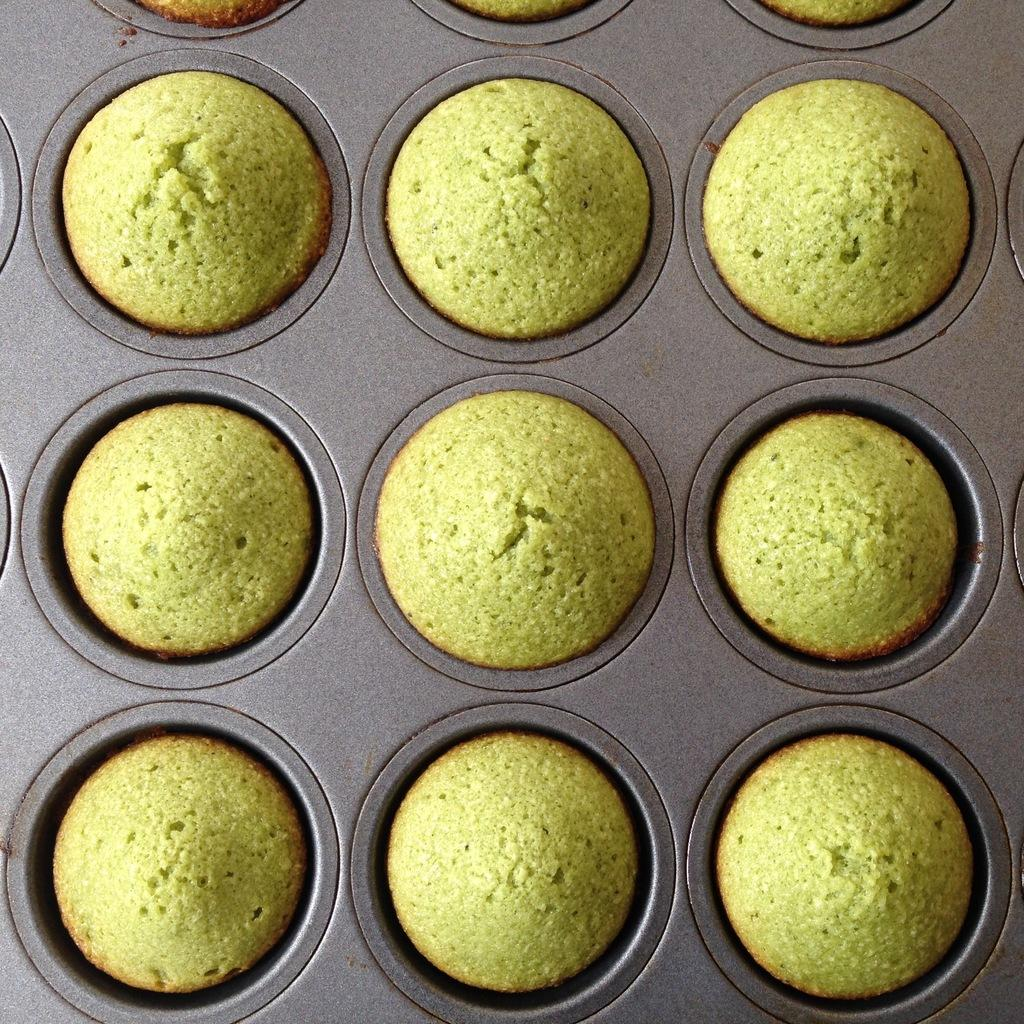What type of food can be seen in the image? There are cookies in a tray in the image. How are the cookies arranged in the tray? The provided facts do not specify the arrangement of the cookies in the tray. What might someone be about to do with the cookies in the image? Someone might be about to eat the cookies or serve them to others. What type of tomatoes can be seen in the image? There are no tomatoes present in the image; it features cookies in a tray. What color is the sock in the image? There is no sock present in the image. 